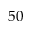<formula> <loc_0><loc_0><loc_500><loc_500>5 0</formula> 